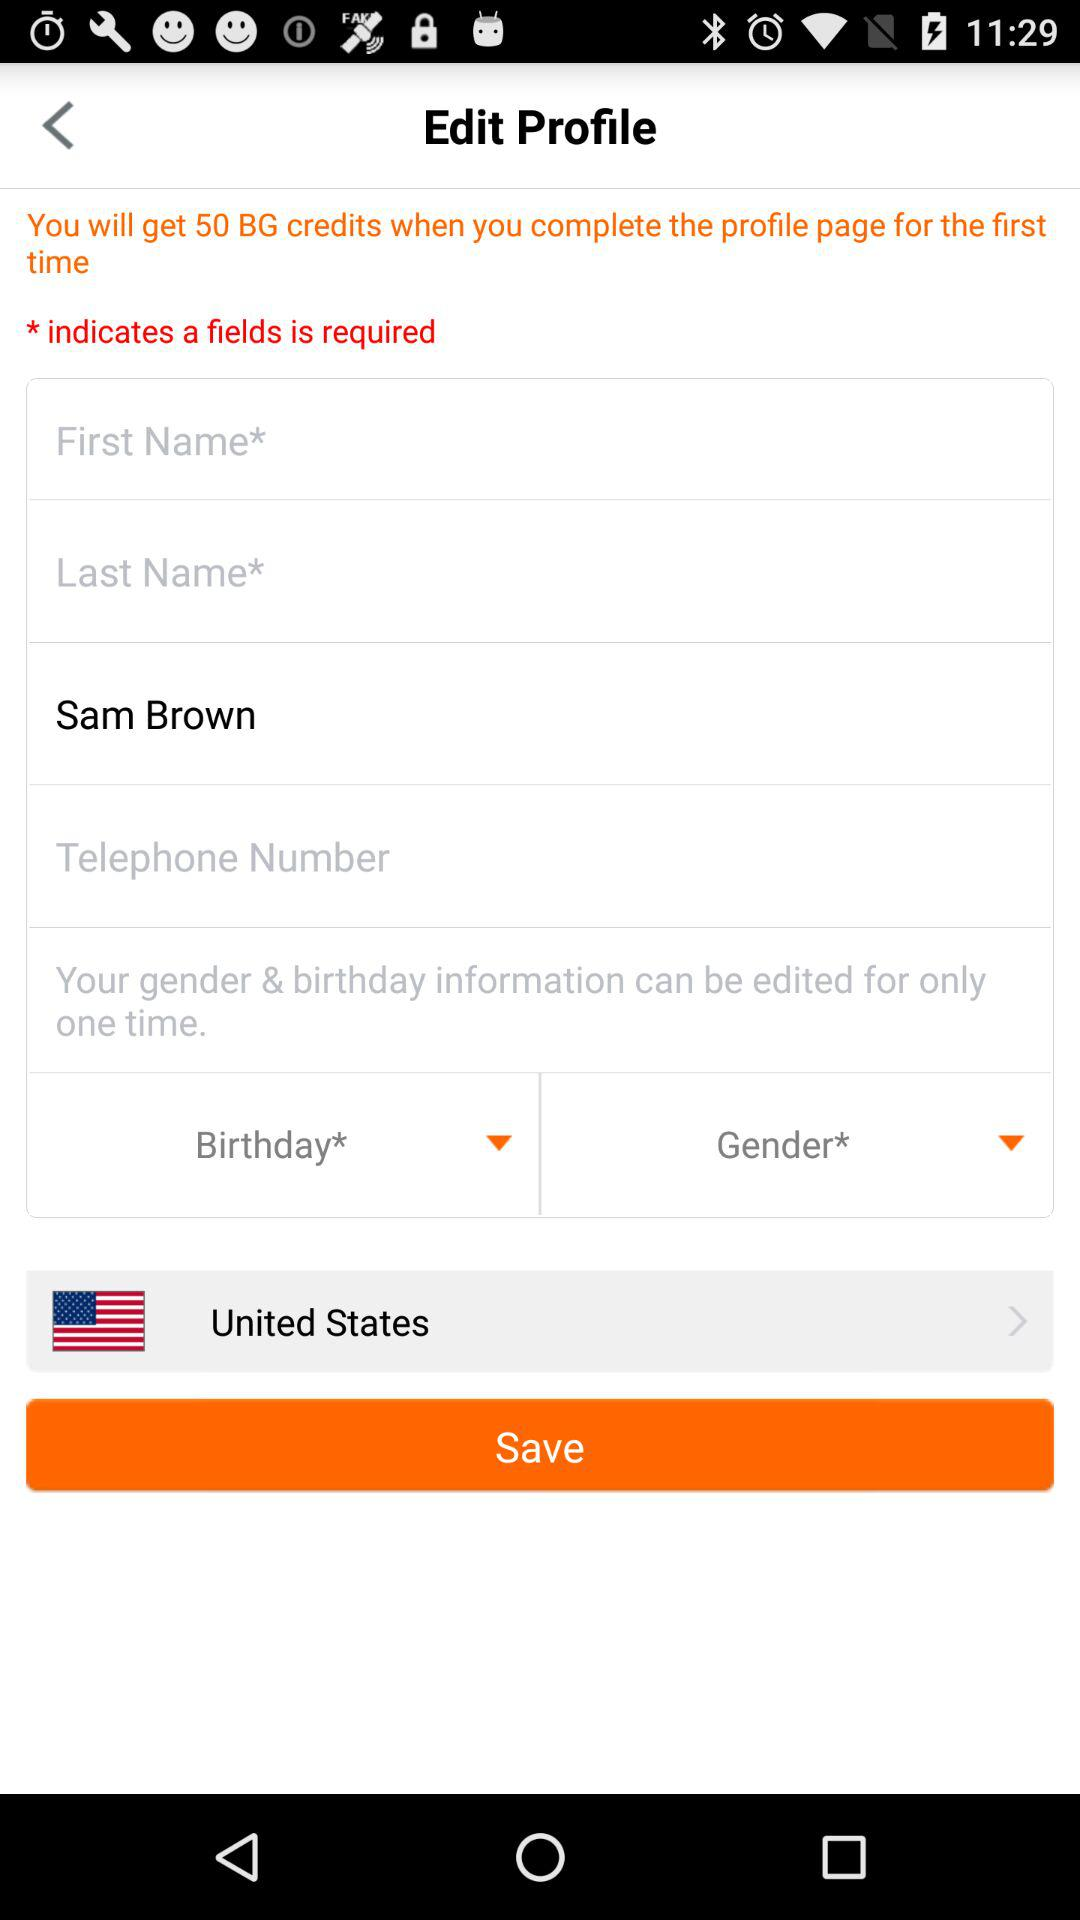How many input fields have a required asterisk?
Answer the question using a single word or phrase. 3 